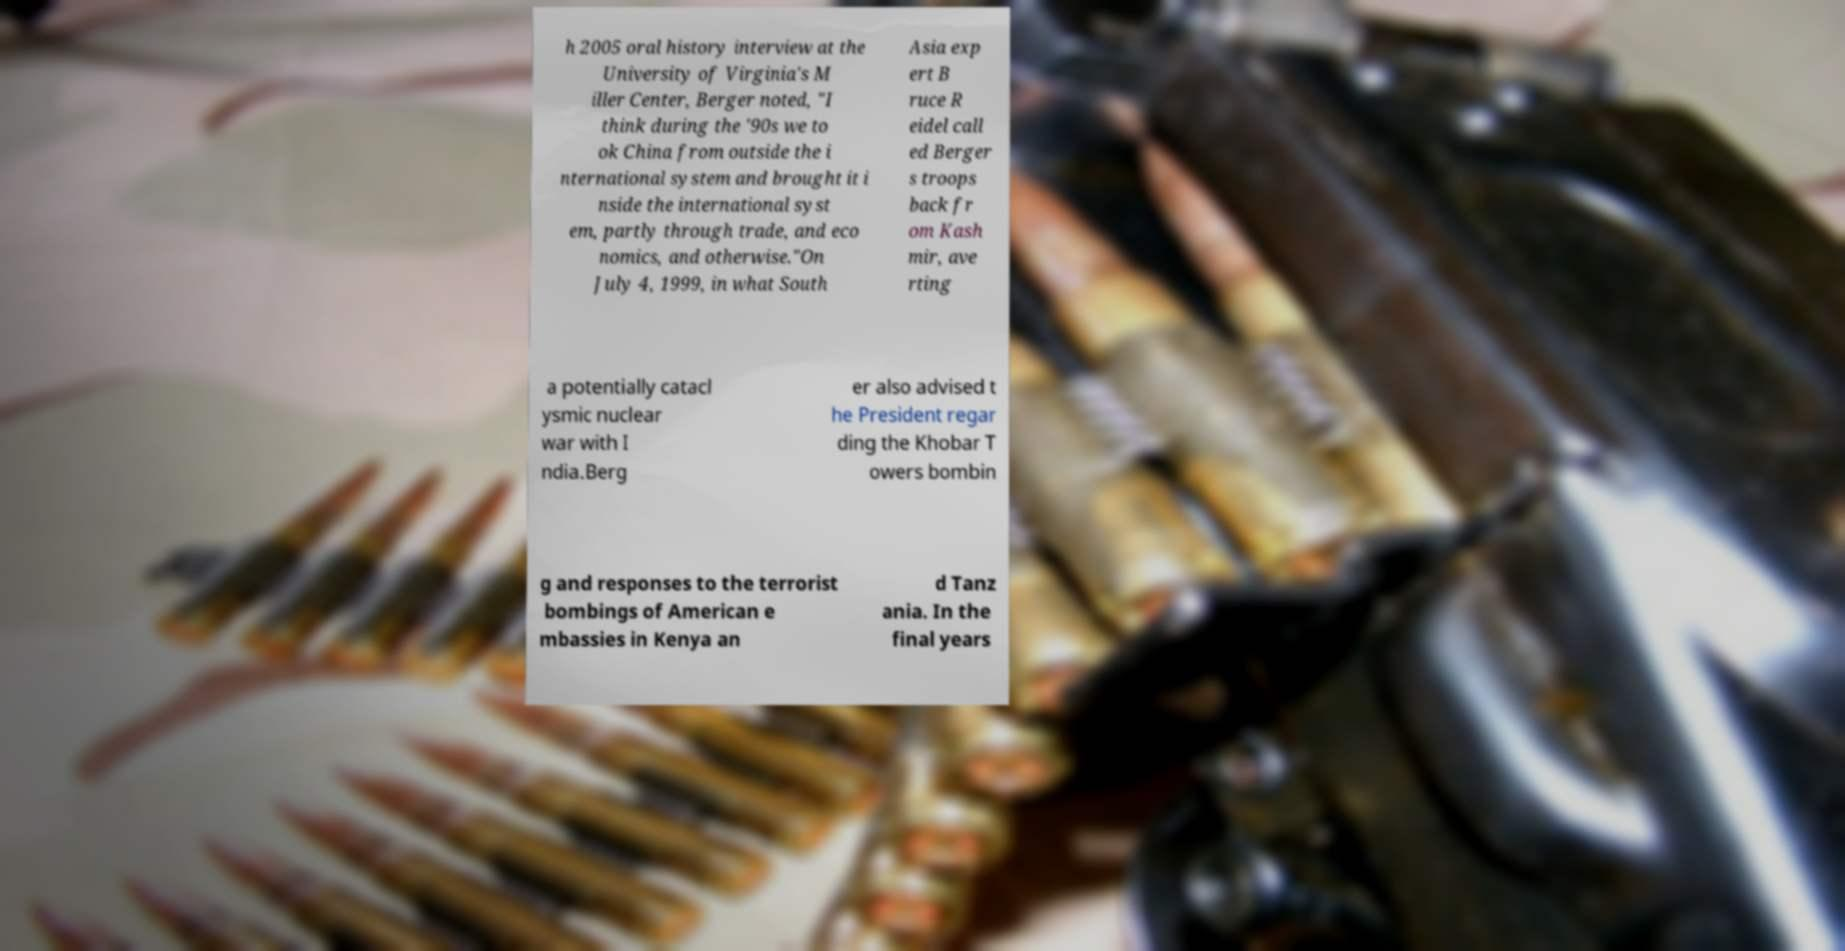Please identify and transcribe the text found in this image. h 2005 oral history interview at the University of Virginia's M iller Center, Berger noted, "I think during the '90s we to ok China from outside the i nternational system and brought it i nside the international syst em, partly through trade, and eco nomics, and otherwise."On July 4, 1999, in what South Asia exp ert B ruce R eidel call ed Berger s troops back fr om Kash mir, ave rting a potentially catacl ysmic nuclear war with I ndia.Berg er also advised t he President regar ding the Khobar T owers bombin g and responses to the terrorist bombings of American e mbassies in Kenya an d Tanz ania. In the final years 